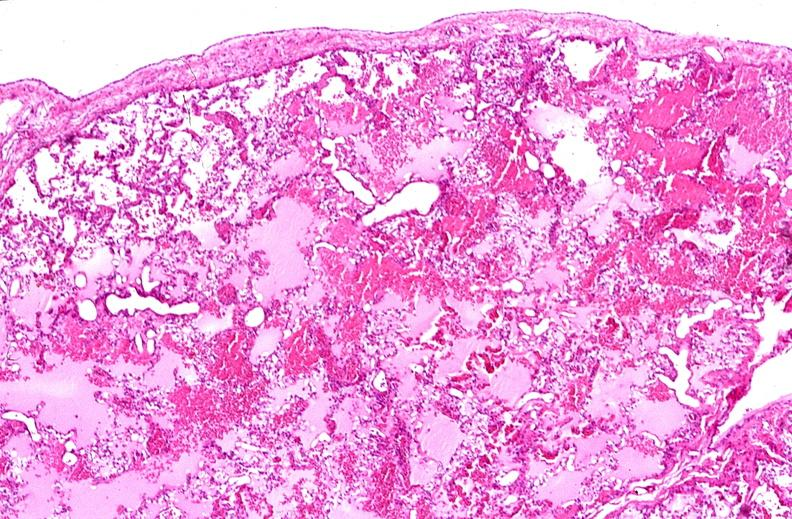what is present?
Answer the question using a single word or phrase. Respiratory 